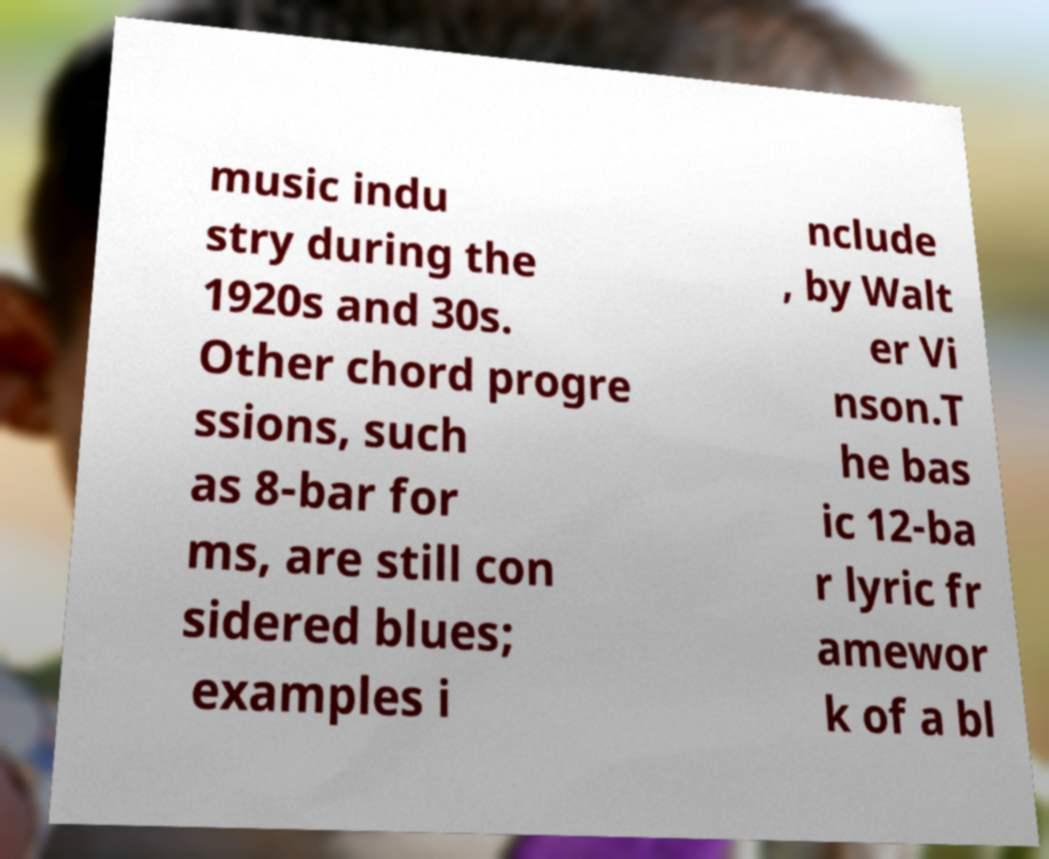I need the written content from this picture converted into text. Can you do that? music indu stry during the 1920s and 30s. Other chord progre ssions, such as 8-bar for ms, are still con sidered blues; examples i nclude , by Walt er Vi nson.T he bas ic 12-ba r lyric fr amewor k of a bl 